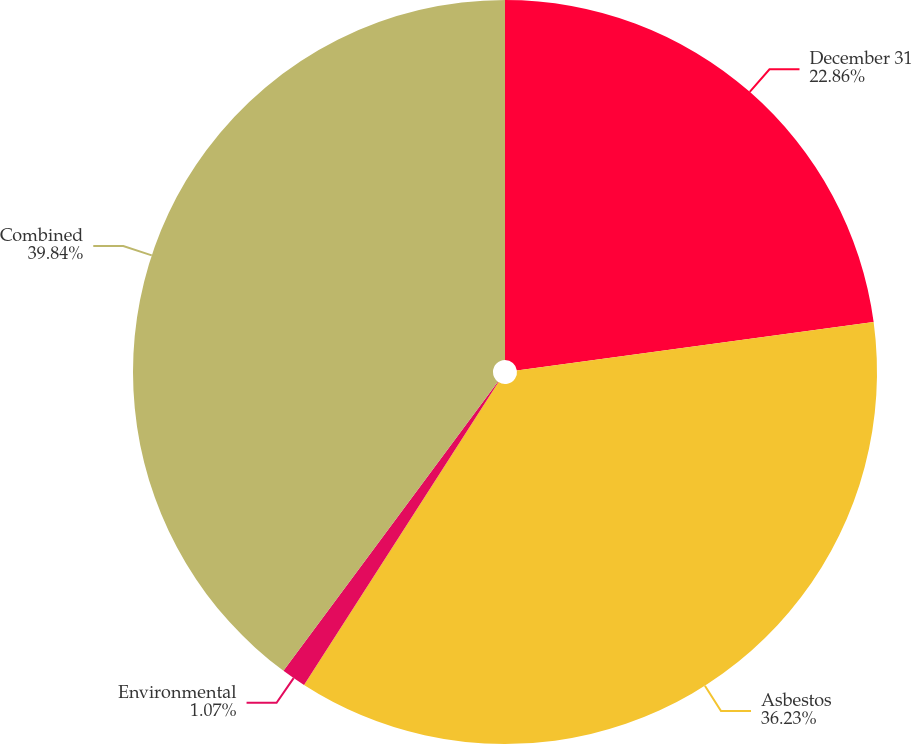Convert chart to OTSL. <chart><loc_0><loc_0><loc_500><loc_500><pie_chart><fcel>December 31<fcel>Asbestos<fcel>Environmental<fcel>Combined<nl><fcel>22.86%<fcel>36.23%<fcel>1.07%<fcel>39.85%<nl></chart> 